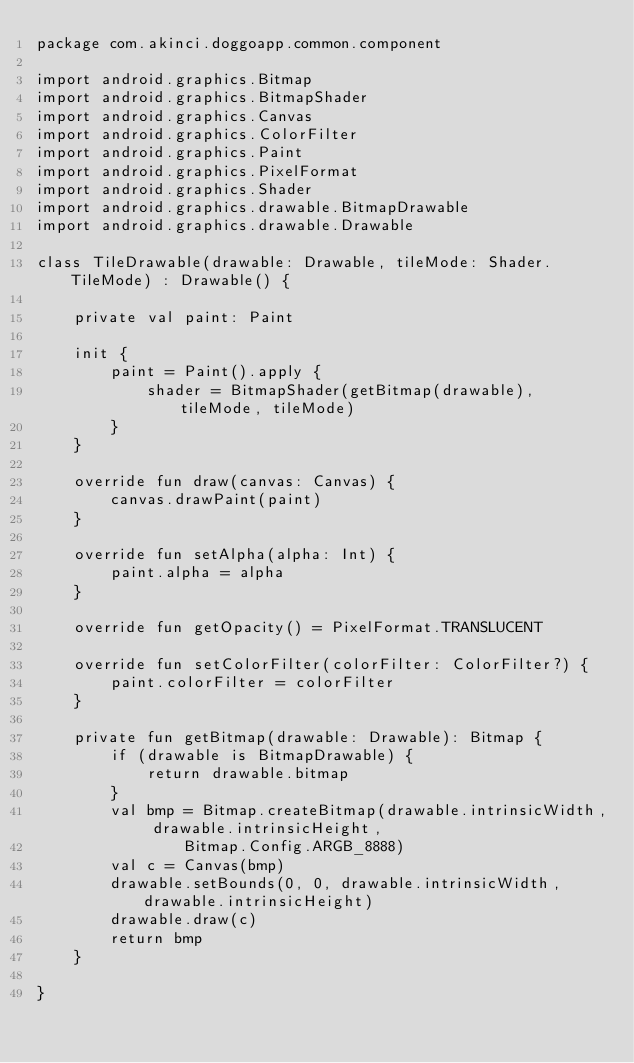<code> <loc_0><loc_0><loc_500><loc_500><_Kotlin_>package com.akinci.doggoapp.common.component

import android.graphics.Bitmap
import android.graphics.BitmapShader
import android.graphics.Canvas
import android.graphics.ColorFilter
import android.graphics.Paint
import android.graphics.PixelFormat
import android.graphics.Shader
import android.graphics.drawable.BitmapDrawable
import android.graphics.drawable.Drawable

class TileDrawable(drawable: Drawable, tileMode: Shader.TileMode) : Drawable() {

    private val paint: Paint

    init {
        paint = Paint().apply {
            shader = BitmapShader(getBitmap(drawable), tileMode, tileMode)
        }
    }

    override fun draw(canvas: Canvas) {
        canvas.drawPaint(paint)
    }

    override fun setAlpha(alpha: Int) {
        paint.alpha = alpha
    }

    override fun getOpacity() = PixelFormat.TRANSLUCENT

    override fun setColorFilter(colorFilter: ColorFilter?) {
        paint.colorFilter = colorFilter
    }

    private fun getBitmap(drawable: Drawable): Bitmap {
        if (drawable is BitmapDrawable) {
            return drawable.bitmap
        }
        val bmp = Bitmap.createBitmap(drawable.intrinsicWidth, drawable.intrinsicHeight,
                Bitmap.Config.ARGB_8888)
        val c = Canvas(bmp)
        drawable.setBounds(0, 0, drawable.intrinsicWidth, drawable.intrinsicHeight)
        drawable.draw(c)
        return bmp
    }

}</code> 